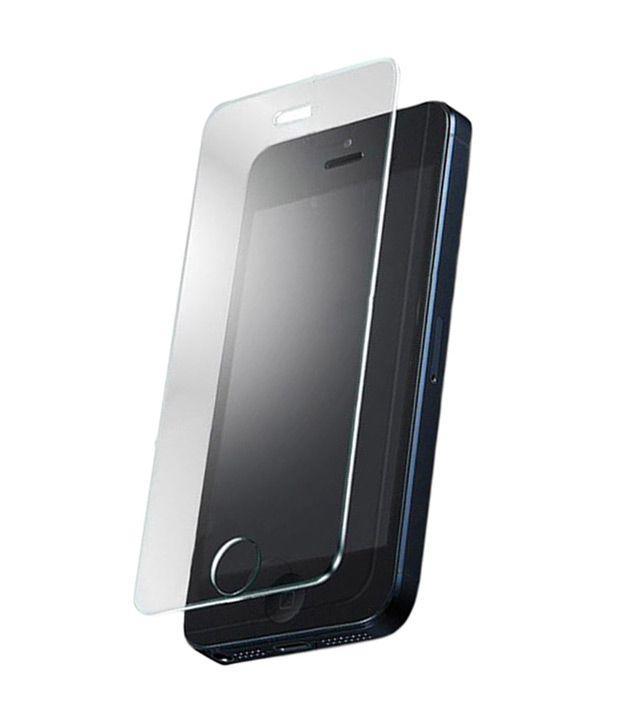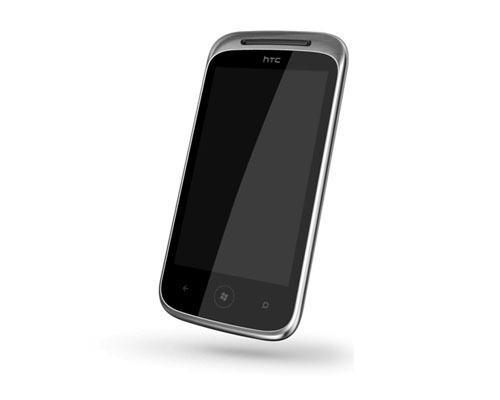The first image is the image on the left, the second image is the image on the right. Considering the images on both sides, is "The image on the left shows a screen protector hovering over a phone." valid? Answer yes or no. Yes. The first image is the image on the left, the second image is the image on the right. Given the left and right images, does the statement "In one of the images you can see a screen protector being applied to the front of a smartphone." hold true? Answer yes or no. Yes. 